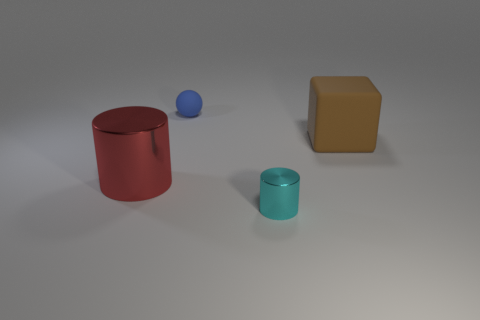Does the red cylinder have the same material as the small object behind the big brown block?
Your response must be concise. No. Is there a brown object of the same size as the ball?
Ensure brevity in your answer.  No. Are there the same number of small rubber things that are to the left of the tiny sphere and big red shiny objects?
Provide a short and direct response. No. What is the size of the cyan metal object?
Your response must be concise. Small. How many big brown matte objects are in front of the cylinder to the right of the large red shiny object?
Your answer should be compact. 0. What shape is the thing that is in front of the large matte object and behind the small metallic thing?
Give a very brief answer. Cylinder. What number of matte objects have the same color as the tiny metal cylinder?
Offer a very short reply. 0. There is a cylinder on the right side of the metal object that is to the left of the rubber ball; is there a small metallic cylinder that is behind it?
Your answer should be compact. No. There is a thing that is both behind the big red thing and in front of the blue sphere; how big is it?
Provide a succinct answer. Large. How many red objects have the same material as the tiny ball?
Make the answer very short. 0. 